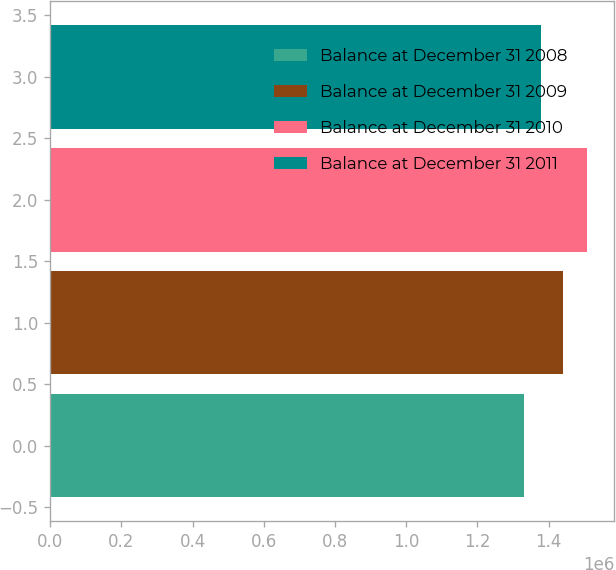Convert chart. <chart><loc_0><loc_0><loc_500><loc_500><bar_chart><fcel>Balance at December 31 2008<fcel>Balance at December 31 2009<fcel>Balance at December 31 2010<fcel>Balance at December 31 2011<nl><fcel>1.33214e+06<fcel>1.44176e+06<fcel>1.50921e+06<fcel>1.38012e+06<nl></chart> 